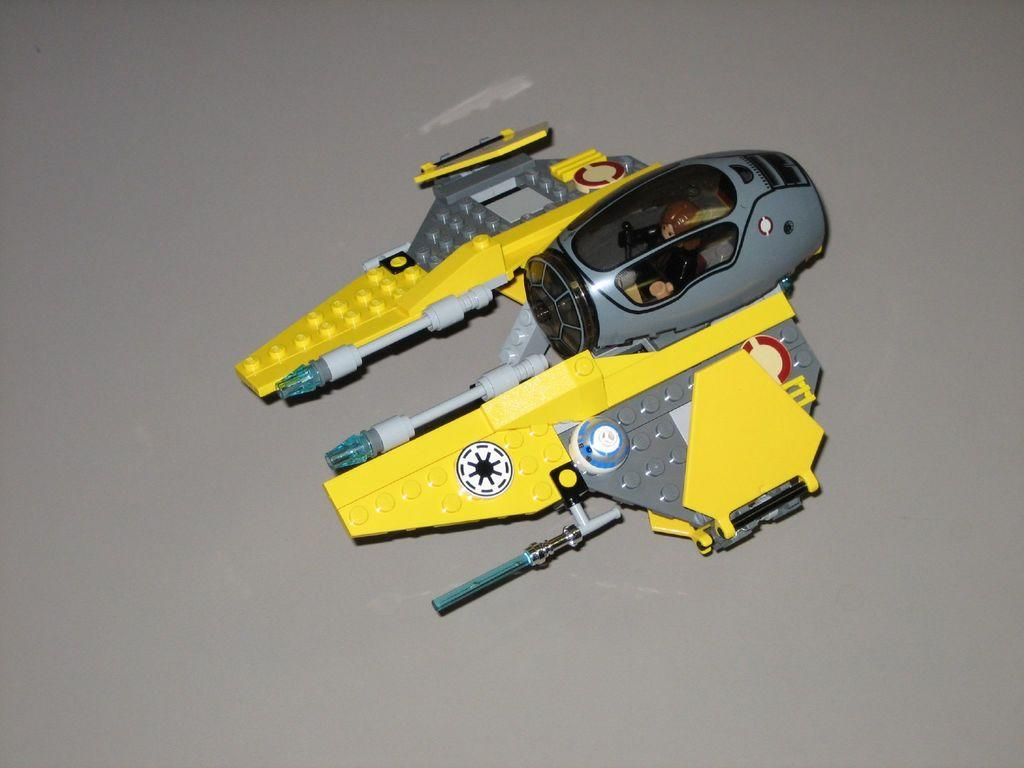What is the main object in the image? There is a toy in the image. Can you describe the colors of the toy? The toy has yellow and ash colors. What color is the background of the image? The background of the image is in ash color. Can you see any veins in the toy? There are no veins present in the toy, as it is an inanimate object. 